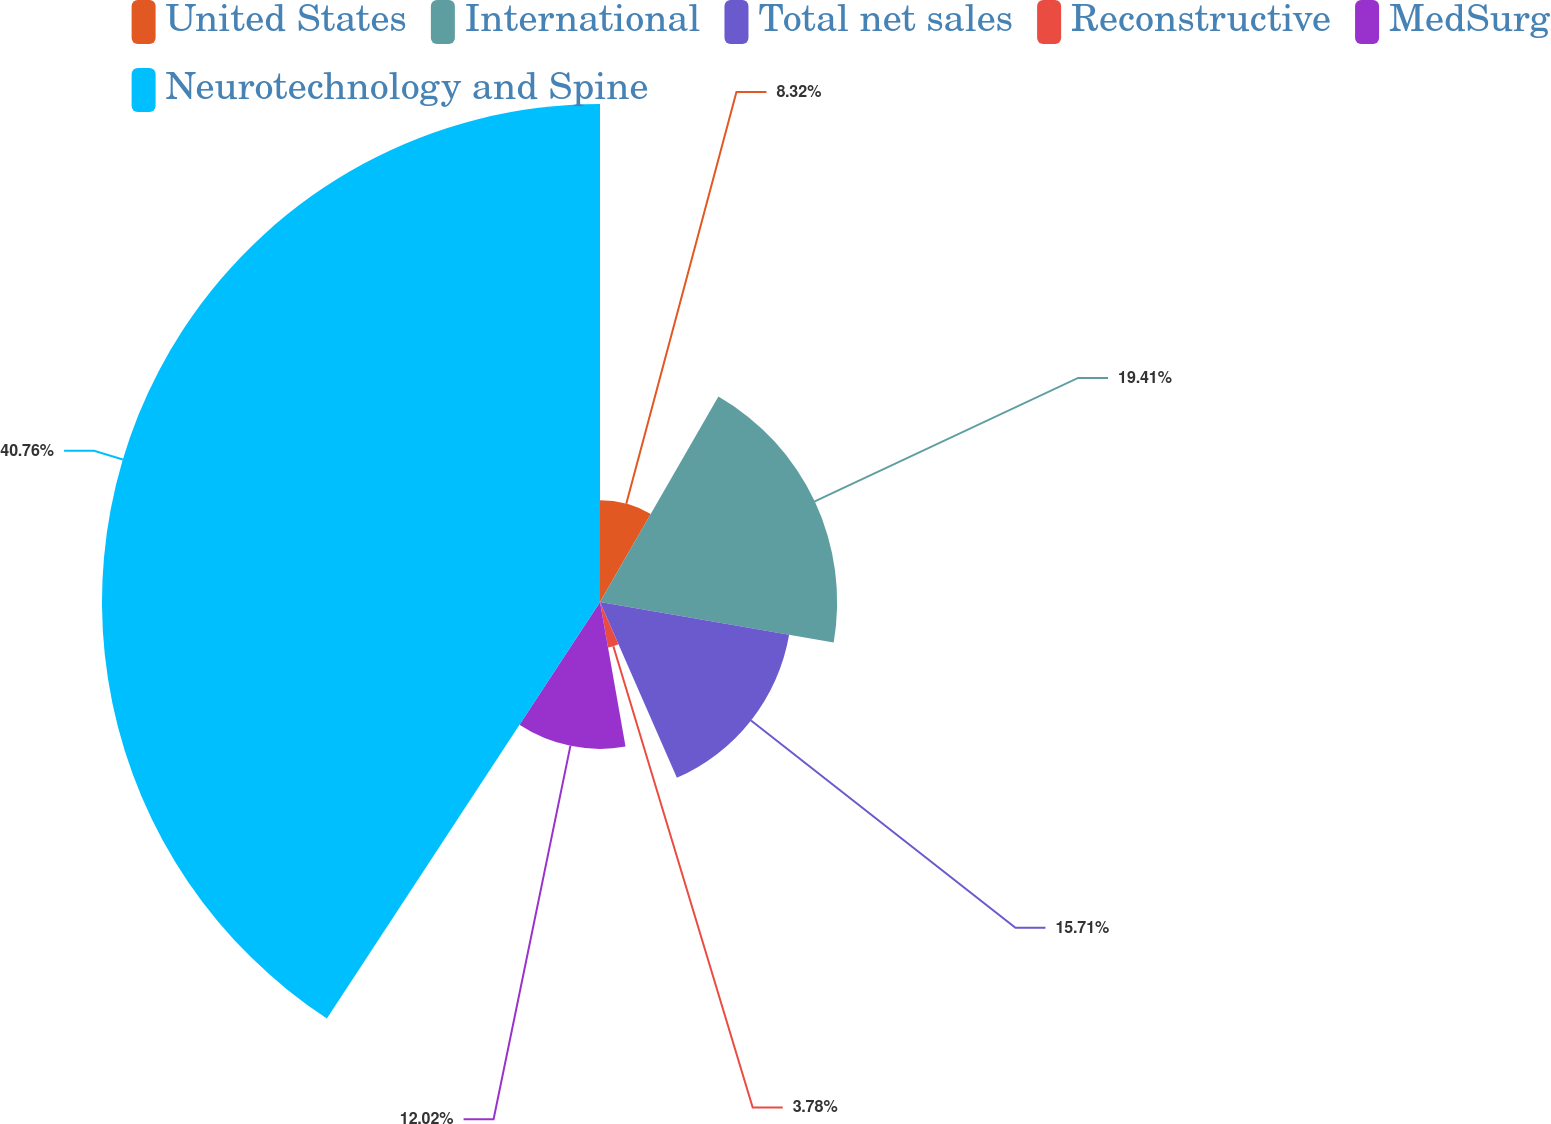Convert chart to OTSL. <chart><loc_0><loc_0><loc_500><loc_500><pie_chart><fcel>United States<fcel>International<fcel>Total net sales<fcel>Reconstructive<fcel>MedSurg<fcel>Neurotechnology and Spine<nl><fcel>8.32%<fcel>19.41%<fcel>15.71%<fcel>3.78%<fcel>12.02%<fcel>40.76%<nl></chart> 